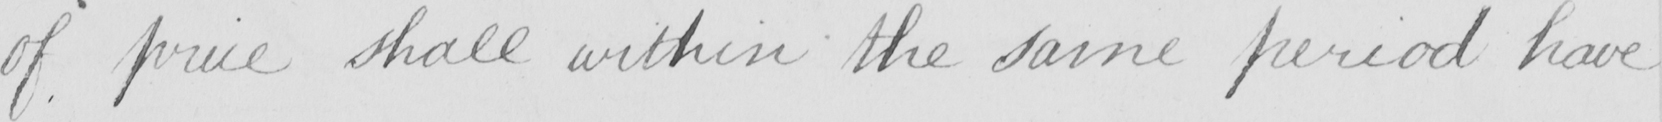What does this handwritten line say? of price shall within the same period have 